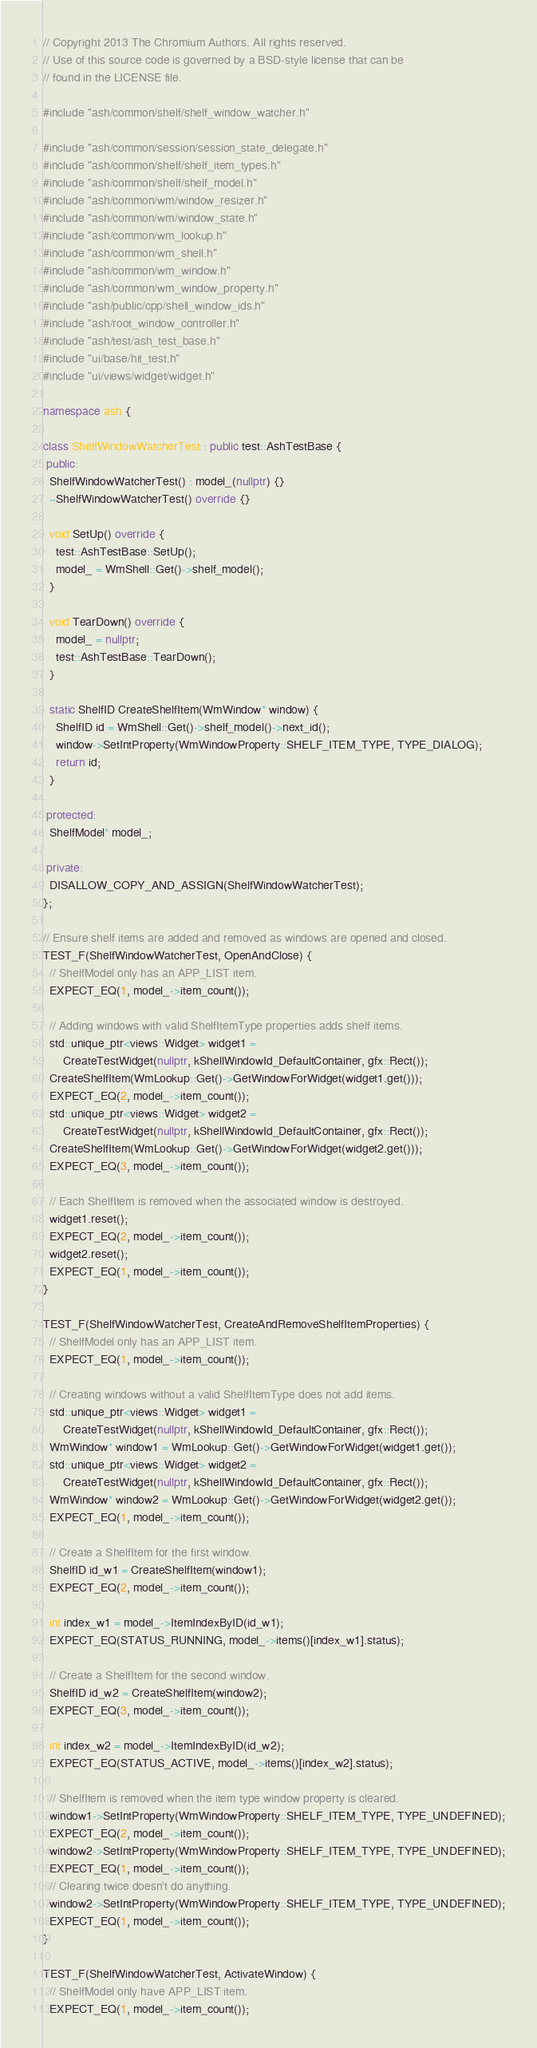<code> <loc_0><loc_0><loc_500><loc_500><_C++_>// Copyright 2013 The Chromium Authors. All rights reserved.
// Use of this source code is governed by a BSD-style license that can be
// found in the LICENSE file.

#include "ash/common/shelf/shelf_window_watcher.h"

#include "ash/common/session/session_state_delegate.h"
#include "ash/common/shelf/shelf_item_types.h"
#include "ash/common/shelf/shelf_model.h"
#include "ash/common/wm/window_resizer.h"
#include "ash/common/wm/window_state.h"
#include "ash/common/wm_lookup.h"
#include "ash/common/wm_shell.h"
#include "ash/common/wm_window.h"
#include "ash/common/wm_window_property.h"
#include "ash/public/cpp/shell_window_ids.h"
#include "ash/root_window_controller.h"
#include "ash/test/ash_test_base.h"
#include "ui/base/hit_test.h"
#include "ui/views/widget/widget.h"

namespace ash {

class ShelfWindowWatcherTest : public test::AshTestBase {
 public:
  ShelfWindowWatcherTest() : model_(nullptr) {}
  ~ShelfWindowWatcherTest() override {}

  void SetUp() override {
    test::AshTestBase::SetUp();
    model_ = WmShell::Get()->shelf_model();
  }

  void TearDown() override {
    model_ = nullptr;
    test::AshTestBase::TearDown();
  }

  static ShelfID CreateShelfItem(WmWindow* window) {
    ShelfID id = WmShell::Get()->shelf_model()->next_id();
    window->SetIntProperty(WmWindowProperty::SHELF_ITEM_TYPE, TYPE_DIALOG);
    return id;
  }

 protected:
  ShelfModel* model_;

 private:
  DISALLOW_COPY_AND_ASSIGN(ShelfWindowWatcherTest);
};

// Ensure shelf items are added and removed as windows are opened and closed.
TEST_F(ShelfWindowWatcherTest, OpenAndClose) {
  // ShelfModel only has an APP_LIST item.
  EXPECT_EQ(1, model_->item_count());

  // Adding windows with valid ShelfItemType properties adds shelf items.
  std::unique_ptr<views::Widget> widget1 =
      CreateTestWidget(nullptr, kShellWindowId_DefaultContainer, gfx::Rect());
  CreateShelfItem(WmLookup::Get()->GetWindowForWidget(widget1.get()));
  EXPECT_EQ(2, model_->item_count());
  std::unique_ptr<views::Widget> widget2 =
      CreateTestWidget(nullptr, kShellWindowId_DefaultContainer, gfx::Rect());
  CreateShelfItem(WmLookup::Get()->GetWindowForWidget(widget2.get()));
  EXPECT_EQ(3, model_->item_count());

  // Each ShelfItem is removed when the associated window is destroyed.
  widget1.reset();
  EXPECT_EQ(2, model_->item_count());
  widget2.reset();
  EXPECT_EQ(1, model_->item_count());
}

TEST_F(ShelfWindowWatcherTest, CreateAndRemoveShelfItemProperties) {
  // ShelfModel only has an APP_LIST item.
  EXPECT_EQ(1, model_->item_count());

  // Creating windows without a valid ShelfItemType does not add items.
  std::unique_ptr<views::Widget> widget1 =
      CreateTestWidget(nullptr, kShellWindowId_DefaultContainer, gfx::Rect());
  WmWindow* window1 = WmLookup::Get()->GetWindowForWidget(widget1.get());
  std::unique_ptr<views::Widget> widget2 =
      CreateTestWidget(nullptr, kShellWindowId_DefaultContainer, gfx::Rect());
  WmWindow* window2 = WmLookup::Get()->GetWindowForWidget(widget2.get());
  EXPECT_EQ(1, model_->item_count());

  // Create a ShelfItem for the first window.
  ShelfID id_w1 = CreateShelfItem(window1);
  EXPECT_EQ(2, model_->item_count());

  int index_w1 = model_->ItemIndexByID(id_w1);
  EXPECT_EQ(STATUS_RUNNING, model_->items()[index_w1].status);

  // Create a ShelfItem for the second window.
  ShelfID id_w2 = CreateShelfItem(window2);
  EXPECT_EQ(3, model_->item_count());

  int index_w2 = model_->ItemIndexByID(id_w2);
  EXPECT_EQ(STATUS_ACTIVE, model_->items()[index_w2].status);

  // ShelfItem is removed when the item type window property is cleared.
  window1->SetIntProperty(WmWindowProperty::SHELF_ITEM_TYPE, TYPE_UNDEFINED);
  EXPECT_EQ(2, model_->item_count());
  window2->SetIntProperty(WmWindowProperty::SHELF_ITEM_TYPE, TYPE_UNDEFINED);
  EXPECT_EQ(1, model_->item_count());
  // Clearing twice doesn't do anything.
  window2->SetIntProperty(WmWindowProperty::SHELF_ITEM_TYPE, TYPE_UNDEFINED);
  EXPECT_EQ(1, model_->item_count());
}

TEST_F(ShelfWindowWatcherTest, ActivateWindow) {
  // ShelfModel only have APP_LIST item.
  EXPECT_EQ(1, model_->item_count());</code> 